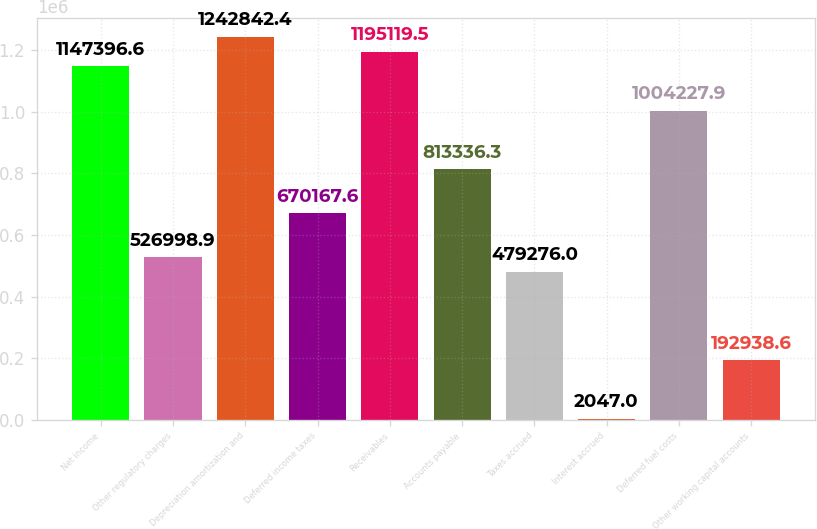Convert chart to OTSL. <chart><loc_0><loc_0><loc_500><loc_500><bar_chart><fcel>Net income<fcel>Other regulatory charges<fcel>Depreciation amortization and<fcel>Deferred income taxes<fcel>Receivables<fcel>Accounts payable<fcel>Taxes accrued<fcel>Interest accrued<fcel>Deferred fuel costs<fcel>Other working capital accounts<nl><fcel>1.1474e+06<fcel>526999<fcel>1.24284e+06<fcel>670168<fcel>1.19512e+06<fcel>813336<fcel>479276<fcel>2047<fcel>1.00423e+06<fcel>192939<nl></chart> 